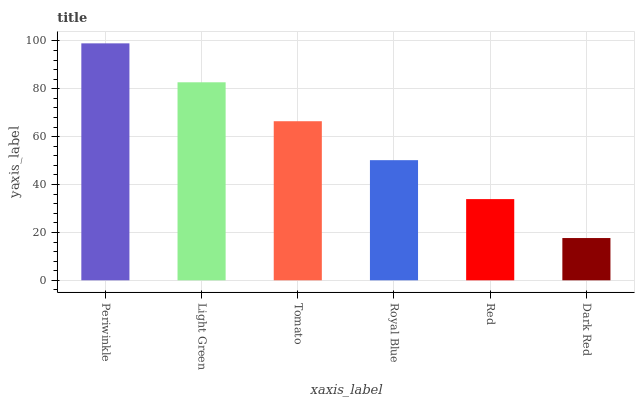Is Dark Red the minimum?
Answer yes or no. Yes. Is Periwinkle the maximum?
Answer yes or no. Yes. Is Light Green the minimum?
Answer yes or no. No. Is Light Green the maximum?
Answer yes or no. No. Is Periwinkle greater than Light Green?
Answer yes or no. Yes. Is Light Green less than Periwinkle?
Answer yes or no. Yes. Is Light Green greater than Periwinkle?
Answer yes or no. No. Is Periwinkle less than Light Green?
Answer yes or no. No. Is Tomato the high median?
Answer yes or no. Yes. Is Royal Blue the low median?
Answer yes or no. Yes. Is Red the high median?
Answer yes or no. No. Is Light Green the low median?
Answer yes or no. No. 